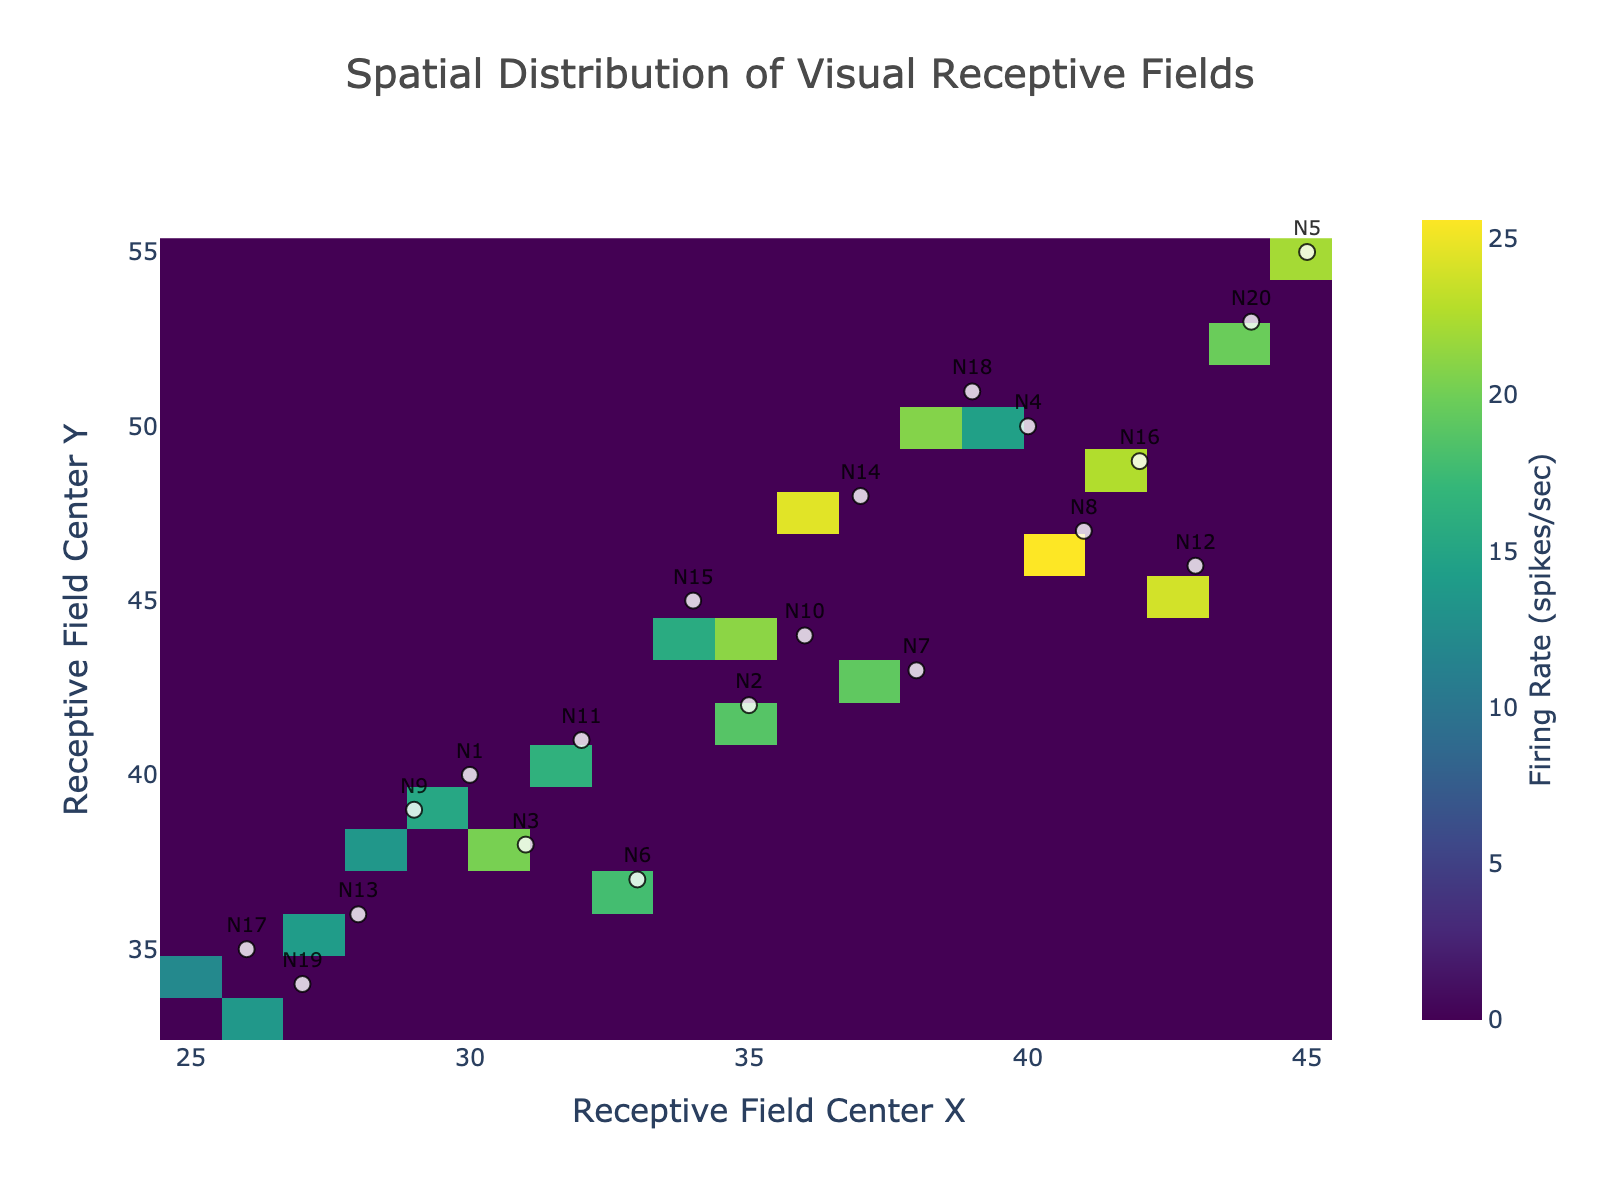What's the title of the figure? You can find the title at the top of the figure. It reads "Spatial Distribution of Visual Receptive Fields."
Answer: Spatial Distribution of Visual Receptive Fields What do the X and Y axes represent? The X-axis represents "Receptive Field Center X," and the Y-axis represents "Receptive Field Center Y," indicating the spatial coordinates of the receptive fields.
Answer: Receptive Field Center X and Receptive Field Center Y Describe the color scale used in the heatmap. The color scale ranges from dark colors for lower firing rates to bright colors for higher firing rates. It uses the 'Viridis' color scheme, with the darkest color representing the minimum and the brightest representing the maximum firing rate in spikes per second.
Answer: Dark to bright colors, Viridis Which neuron has the highest firing rate? Locate the brightest color on the heatmap, then find the neuron marker closest to that location. The neuron closest to the brightest region corresponds to Neuron N8.
Answer: Neuron N8 How many bins are used on the X-axis? The number of bins on the X-axis can be determined by noting the intervals used. There are 20 bins, as specified in the creation process.
Answer: 20 bins Which area shows the highest concentration of receptive fields? Look for the area with the highest density of receptive field markers. The highest concentration of receptive fields is around coordinates (40, 50) to (45, 55).
Answer: (40, 50) to (45, 55) What is the firing rate for Neuron N13, and how does it compare to Neuron N5? Check the firing rates in the table for both neurons. Neuron N13 has a firing rate of 14.0 spikes/sec and Neuron N5 has 22.1 spikes/sec. So, N5 has a higher firing rate.
Answer: N13: 14.0 spikes/sec, N5: 22.1 spikes/sec What can you infer about the spatial distribution of the highest firing rates? The brightest areas indicating higher firing rates are more concentrated around the upper-right region of the heatmap, suggesting neurons in that region tend to have higher firing rates.
Answer: Upper-right region Is there a specific correlation between firing rate and spatial location? Observed through the heatmap, brighter regions are clustered, implying some spatial organization where certain regions have systematically higher firing rates.
Answer: Clusters in specific regions 